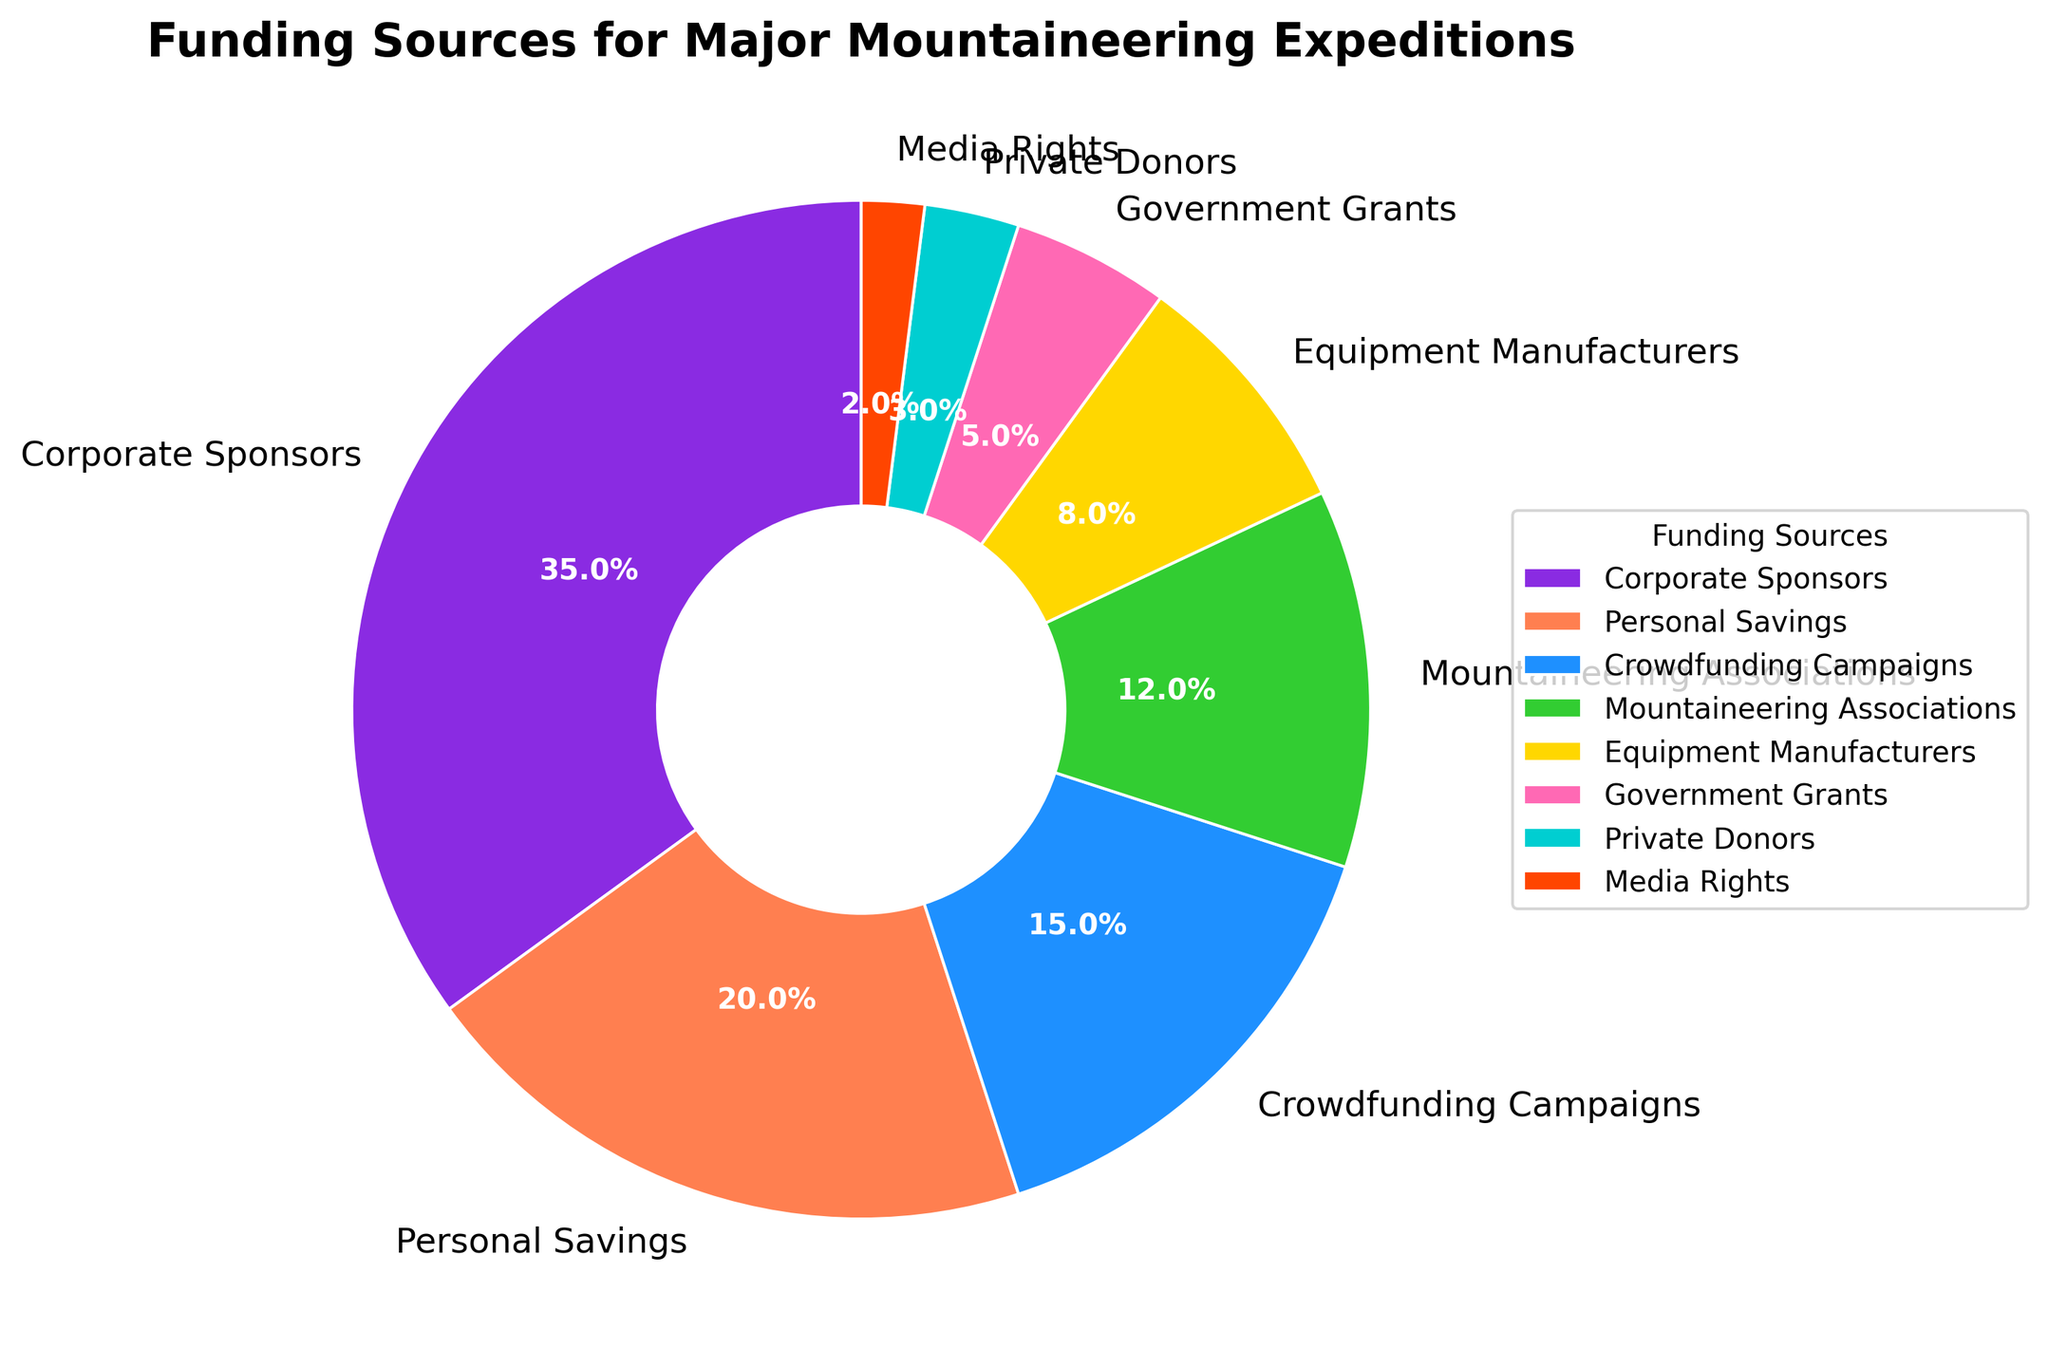What's the largest funding source for major mountaineering expeditions? The largest segment in the pie chart is labeled "Corporate Sponsors" and shows 35%.
Answer: Corporate Sponsors Which funding source contributes the least to major mountaineering expeditions? The smallest segment is labeled "Media Rights" and shows 2%.
Answer: Media Rights What is the combined percentage of funding from "Personal Savings" and "Crowdfunding Campaigns"? The segments for "Personal Savings" and "Crowdfunding Campaigns" show 20% and 15%, respectively. Adding these together: 20% + 15% = 35%.
Answer: 35% Which funding source provides more funds: "Government Grants" or "Equipment Manufacturers"? The segments for "Government Grants" and "Equipment Manufacturers" show 5% and 8%, respectively. 8% is greater than 5%.
Answer: Equipment Manufacturers How much greater is the funding percentage from "Corporate Sponsors" compared to "Mountaineering Associations"? "Corporate Sponsors" contribute 35%, while "Mountaineering Associations" contribute 12%. The difference is 35% - 12% = 23%.
Answer: 23% What is the cumulative percentage of funding provided by "Equipment Manufacturers", "Government Grants", "Private Donors", and "Media Rights"? The segments for "Equipment Manufacturers", "Government Grants", "Private Donors", and "Media Rights" show 8%, 5%, 3%, and 2%, respectively. Summing these percentages: 8% + 5% + 3% + 2% = 18%.
Answer: 18% Are there more funds from "Mountaineering Associations" or "Personal Savings"? The segment for "Personal Savings" shows 20%, while "Mountaineering Associations" shows 12%. 20% is greater than 12%.
Answer: Personal Savings What fraction of the total funding do "Corporate Sponsors" and "Personal Savings" comprise together? Adding the segments for "Corporate Sponsors" and "Personal Savings": 35% + 20% = 55%. They comprise 55% of the total funding.
Answer: 55% Which funding source has a green-colored segment on the pie chart? Among the segments, "Mountaineering Associations" has a green segment.
Answer: Mountaineering Associations Is the funding from "Crowdfunding Campaigns" closer to "Personal Savings" or "Mountaineering Associations"? "Crowdfunding Campaigns" have 15%, "Personal Savings" have 20%, and "Mountaineering Associations" have 12%. The difference between "Crowdfunding Campaigns" and "Personal Savings" is 20% - 15% = 5%, while the difference between "Crowdfunding Campaigns" and "Mountaineering Associations" is 15% - 12% = 3%. 3% is less than 5%.
Answer: Mountaineering Associations 